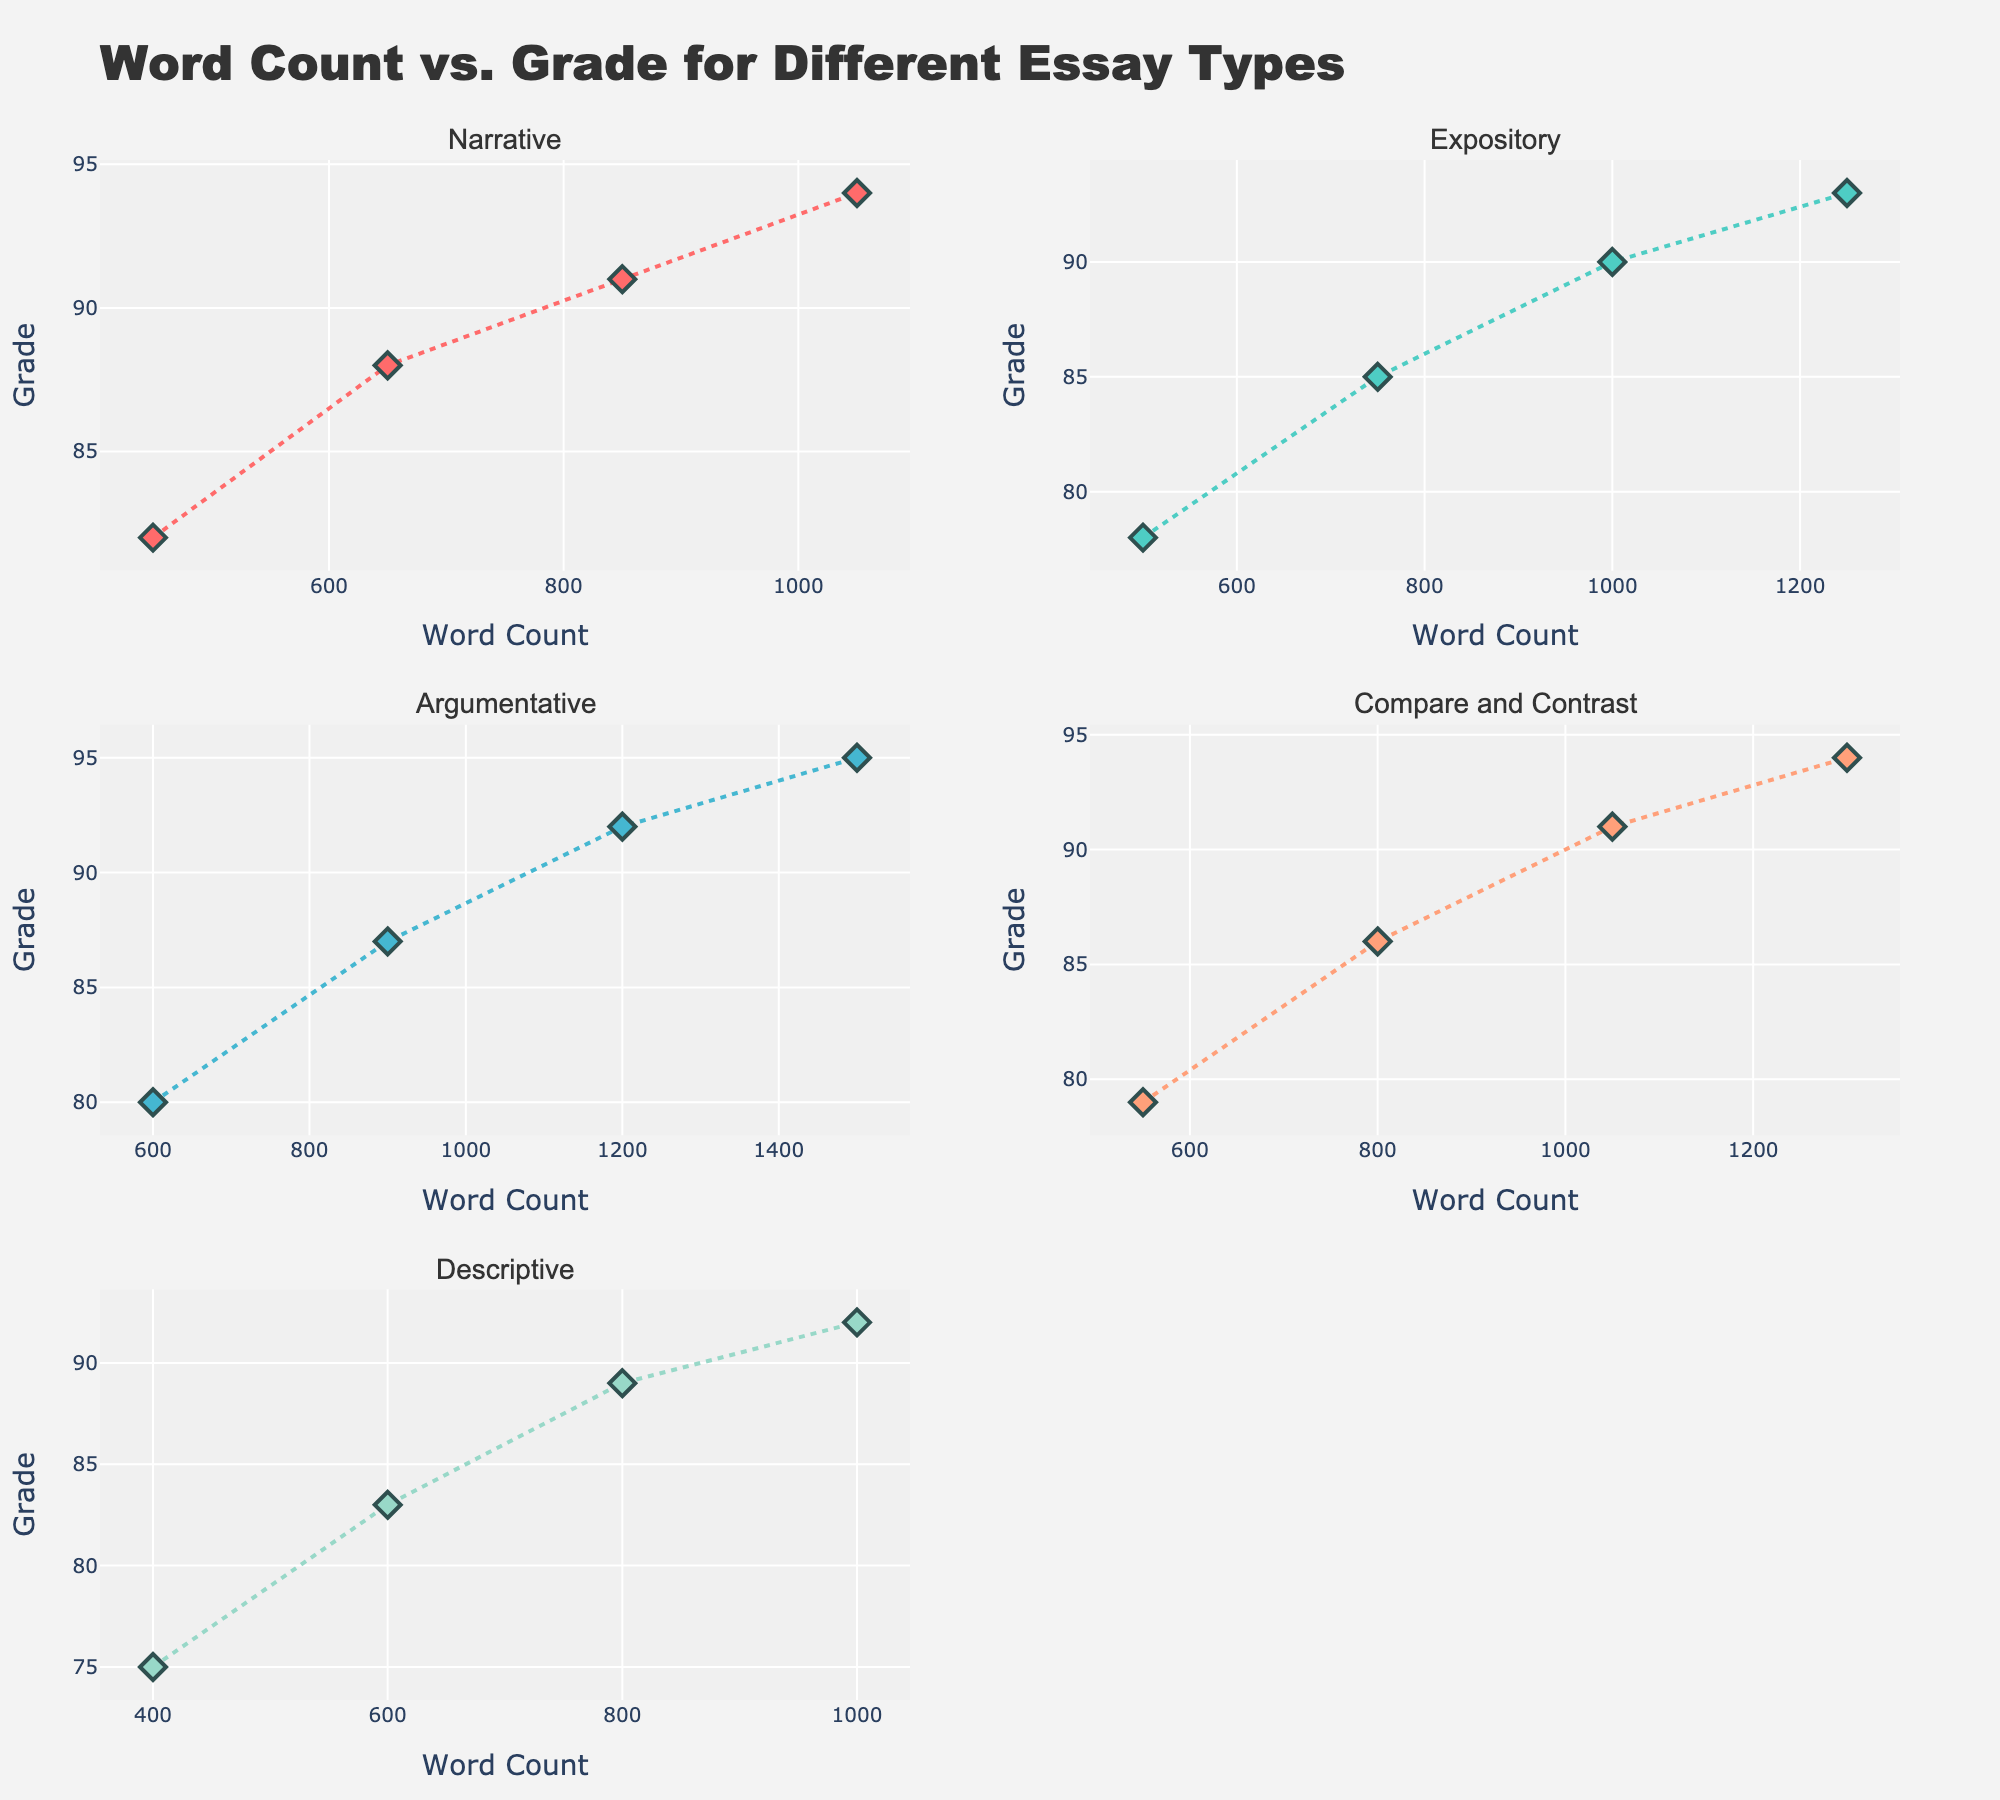What is the title of the figure? The title is clearly displayed at the top of the plot. It reads "Word Count vs. Grade for Different Essay Types."
Answer: Word Count vs. Grade for Different Essay Types How many essay types are displayed in the subplots? Each subplot has a unique title corresponding to an essay type. There are 5 different essay titles: Narrative, Expository, Argumentative, Compare and Contrast, and Descriptive.
Answer: 5 Which essay type has the highest grade for its highest word count? The Descriptive subplot ends with the highest word count of 1000 and the highest grade of 92.
Answer: Descriptive What is the common x-axis label for all subplots, and what does it represent? The x-axis label "Word Count" is consistently used across all subplots, representing the number of words in each essay.
Answer: Word Count What is the y-axis label in each subplot, and what does it represent? The y-axis label in each subplot is "Grade," representing the scores received for the essays.
Answer: Grade What is the color used for the markers in the Narrative essay subplot? The markers for Narrative essays are colored in a reddish hue, specifically #FF6B6B.
Answer: #FF6B6B (reddish hue) In the Expository subplot, which word count corresponds to a grade of 90? Look at the Expository subplot, find the point where the y-axis value is 90, and locate the corresponding x-axis value. It is 1000 words.
Answer: 1000 What is the general trend between word count and grade across all subplots? Observing all subplots, a positive trend where higher word counts tend to correlate with higher grades can be seen.
Answer: Positive correlation Compare the highest grade between Argumentative and Compare and Contrast essay types. The highest grades for Argumentative and Compare and Contrast are 95 and 94, respectively.
Answer: Argumentative: 95, Compare and Contrast: 94 How does the grade change when the word count increases from 550 to 1300 in the Compare and Contrast subplot? In the Compare and Contrast subplot, the grade starts at 79 for 550 words and ends at 94 for 1300 words, showing an increase as the word count increases.
Answer: Increase 